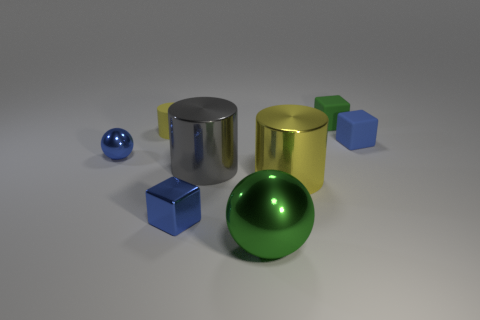What color is the big metal cylinder on the right side of the green thing in front of the tiny green object?
Your answer should be compact. Yellow. Is there a small cylinder that has the same color as the large metallic ball?
Your answer should be very brief. No. How many rubber objects are large green spheres or tiny blue cubes?
Give a very brief answer. 1. Is there a large yellow thing that has the same material as the green block?
Offer a terse response. No. How many small objects are both behind the blue rubber object and to the left of the large yellow cylinder?
Your answer should be very brief. 1. Are there fewer gray objects behind the large green sphere than blue rubber cubes that are left of the large gray shiny object?
Your answer should be very brief. No. Does the large gray object have the same shape as the large yellow thing?
Provide a short and direct response. Yes. How many other things are there of the same size as the gray cylinder?
Your answer should be very brief. 2. How many objects are either cylinders that are to the right of the yellow matte object or tiny objects that are to the left of the small blue matte object?
Your response must be concise. 6. How many small metallic objects have the same shape as the big green metallic object?
Your answer should be compact. 1. 